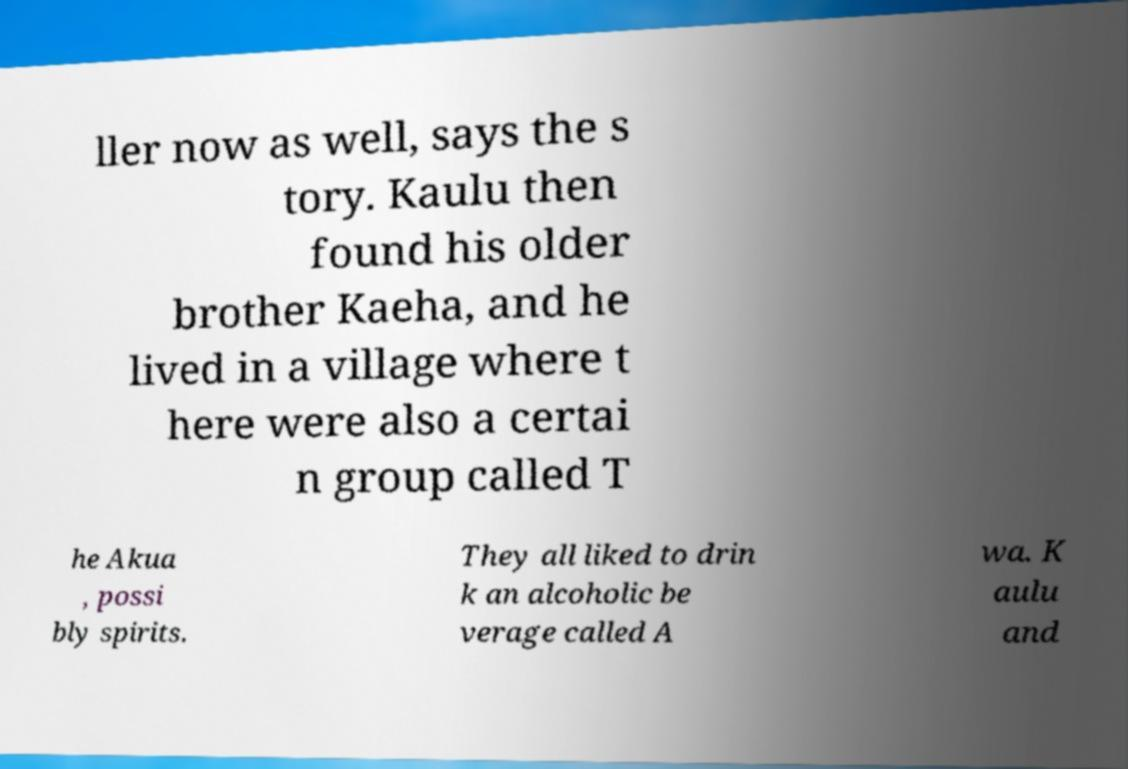I need the written content from this picture converted into text. Can you do that? ller now as well, says the s tory. Kaulu then found his older brother Kaeha, and he lived in a village where t here were also a certai n group called T he Akua , possi bly spirits. They all liked to drin k an alcoholic be verage called A wa. K aulu and 